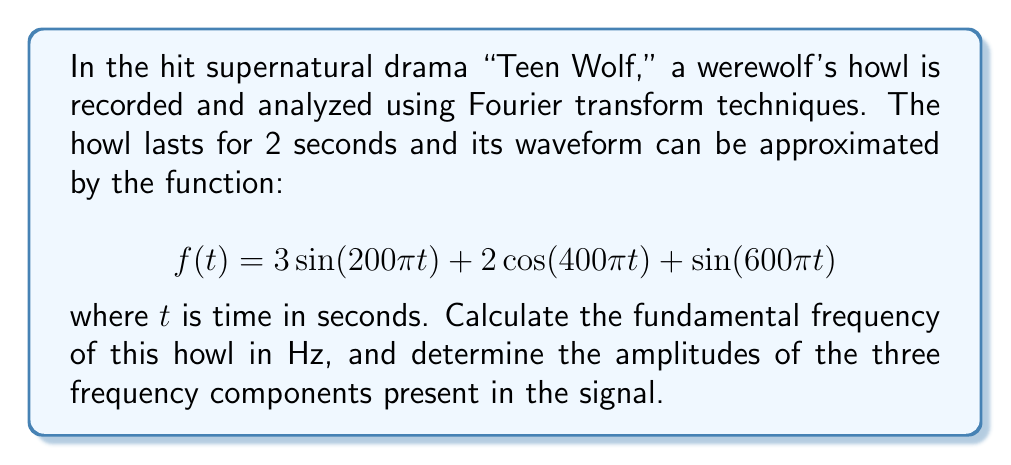Solve this math problem. To solve this problem, we need to analyze the given function and understand the Fourier transform concepts:

1) The fundamental frequency is the lowest frequency component in a periodic signal. To find it, we need to identify the lowest frequency in the given function.

2) In the general form of a sinusoidal function, $A\sin(2\pi ft)$ or $A\cos(2\pi ft)$, $f$ represents the frequency in Hz.

3) Let's analyze each term:
   
   a) $3\sin(200\pi t)$: Here, $200\pi = 2\pi f$, so $f = 100$ Hz
   b) $2\cos(400\pi t)$: Here, $400\pi = 2\pi f$, so $f = 200$ Hz
   c) $\sin(600\pi t)$: Here, $600\pi = 2\pi f$, so $f = 300$ Hz

4) The fundamental frequency is the lowest of these, which is 100 Hz.

5) The amplitudes are the coefficients of each term:
   
   a) For 100 Hz component: 3
   b) For 200 Hz component: 2
   c) For 300 Hz component: 1

Therefore, the howl consists of three frequency components: 100 Hz, 200 Hz, and 300 Hz, with amplitudes 3, 2, and 1 respectively.
Answer: The fundamental frequency is 100 Hz. The amplitudes of the three frequency components are 3 (for 100 Hz), 2 (for 200 Hz), and 1 (for 300 Hz). 